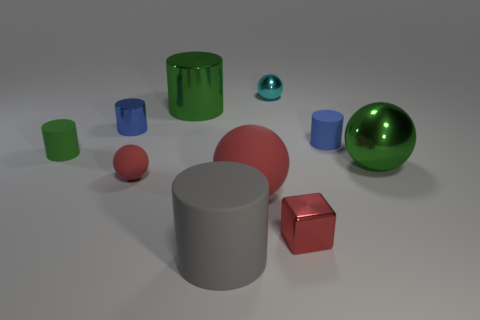Are there any other things that are the same shape as the blue matte thing?
Offer a very short reply. Yes. There is a tiny blue cylinder on the left side of the large green thing to the left of the tiny cyan ball; are there any small blue metallic cylinders that are behind it?
Your answer should be compact. No. How many large spheres have the same material as the red cube?
Offer a terse response. 1. Do the green metal thing that is on the left side of the big green shiny sphere and the cylinder that is to the right of the gray thing have the same size?
Your answer should be very brief. No. There is a small rubber thing in front of the big shiny object that is on the right side of the blue cylinder that is right of the large red thing; what is its color?
Your answer should be compact. Red. Are there any small red objects that have the same shape as the tiny cyan thing?
Keep it short and to the point. Yes. Are there an equal number of rubber cylinders that are in front of the tiny green matte cylinder and green things behind the small blue matte cylinder?
Provide a short and direct response. Yes. Do the big green thing that is to the left of the tiny cyan metallic object and the tiny cyan thing have the same shape?
Offer a very short reply. No. Does the tiny green thing have the same shape as the blue metallic object?
Your answer should be very brief. Yes. How many metal things are big objects or cylinders?
Ensure brevity in your answer.  3. 